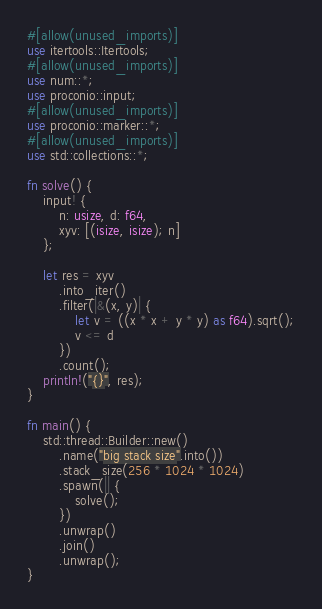Convert code to text. <code><loc_0><loc_0><loc_500><loc_500><_Rust_>#[allow(unused_imports)]
use itertools::Itertools;
#[allow(unused_imports)]
use num::*;
use proconio::input;
#[allow(unused_imports)]
use proconio::marker::*;
#[allow(unused_imports)]
use std::collections::*;

fn solve() {
    input! {
        n: usize, d: f64,
        xyv: [(isize, isize); n]
    };

    let res = xyv
        .into_iter()
        .filter(|&(x, y)| {
            let v = ((x * x + y * y) as f64).sqrt();
            v <= d
        })
        .count();
    println!("{}", res);
}

fn main() {
    std::thread::Builder::new()
        .name("big stack size".into())
        .stack_size(256 * 1024 * 1024)
        .spawn(|| {
            solve();
        })
        .unwrap()
        .join()
        .unwrap();
}
</code> 